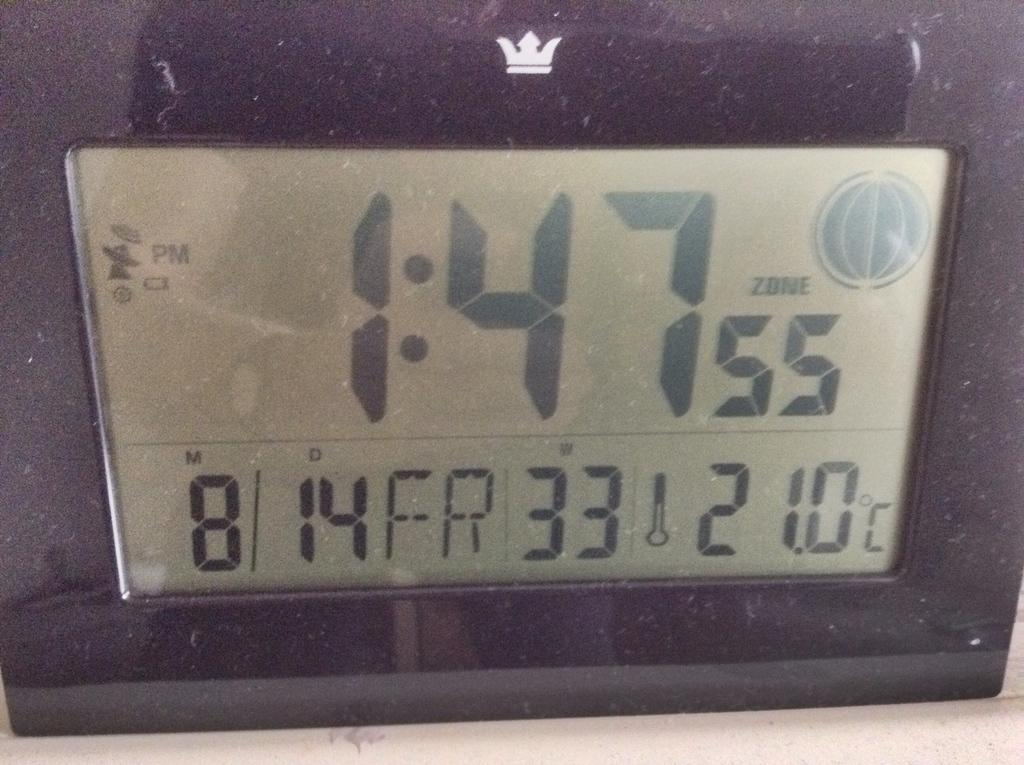What is the main object in the image? There is a speedometer in the image. How many snakes are wrapped around the speedometer in the image? There are no snakes present in the image; it only features a speedometer. Who is the owner of the vehicle with the speedometer in the image? The image does not provide any information about the owner of the vehicle, as it only shows the speedometer. 